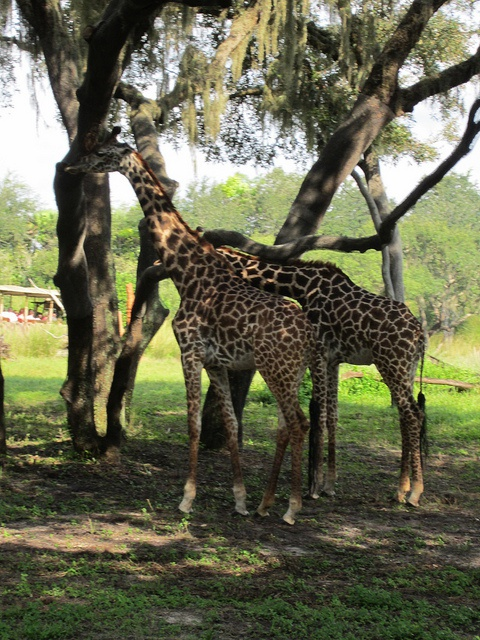Describe the objects in this image and their specific colors. I can see giraffe in gray and black tones and giraffe in gray and black tones in this image. 